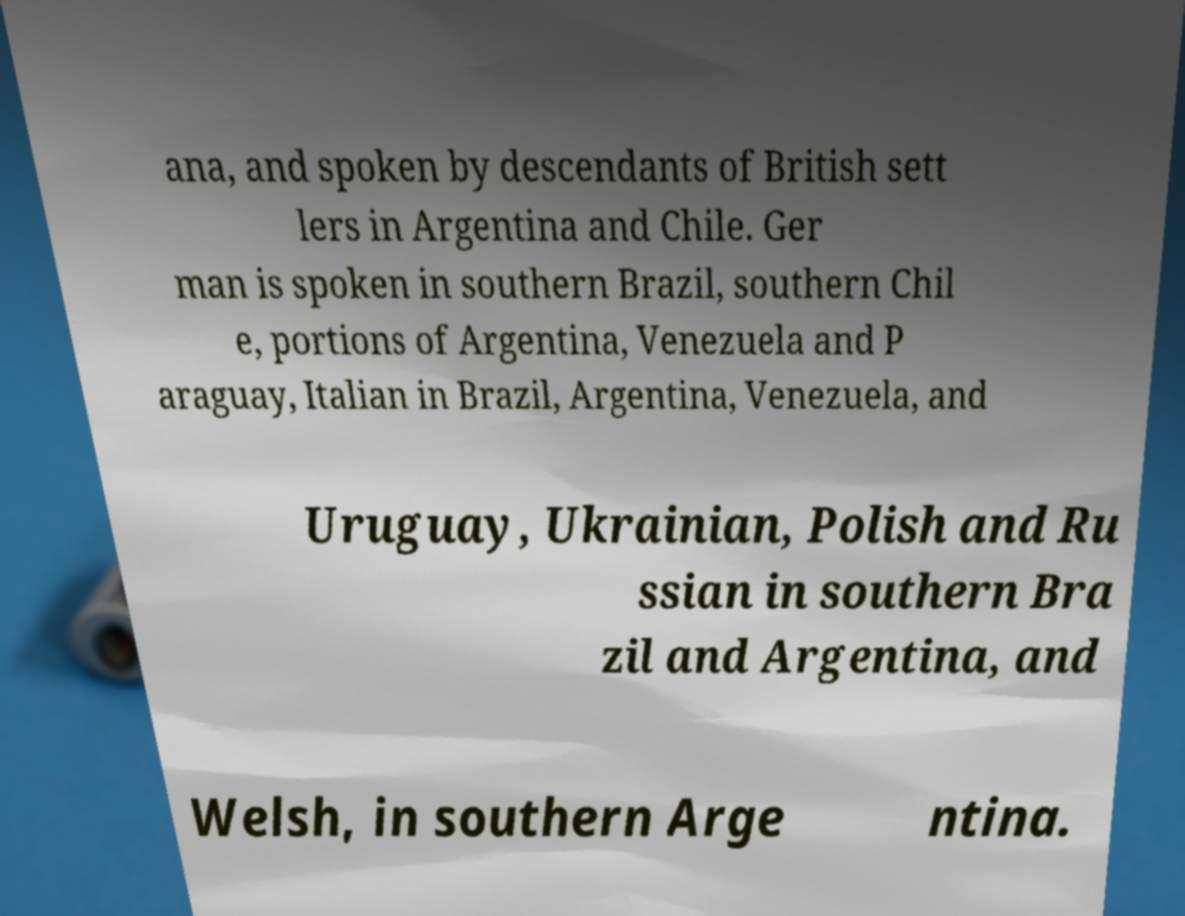There's text embedded in this image that I need extracted. Can you transcribe it verbatim? ana, and spoken by descendants of British sett lers in Argentina and Chile. Ger man is spoken in southern Brazil, southern Chil e, portions of Argentina, Venezuela and P araguay, Italian in Brazil, Argentina, Venezuela, and Uruguay, Ukrainian, Polish and Ru ssian in southern Bra zil and Argentina, and Welsh, in southern Arge ntina. 